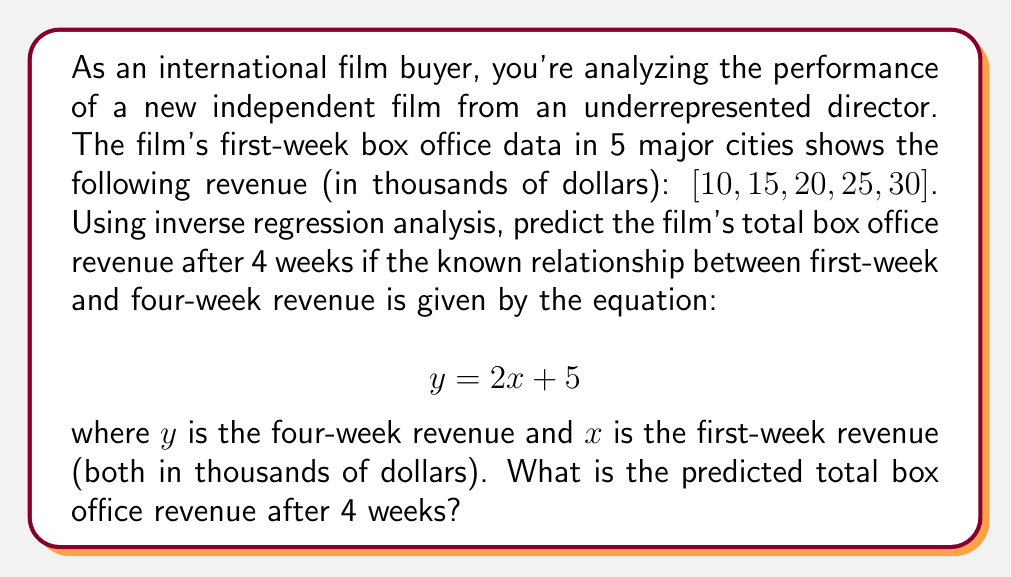Teach me how to tackle this problem. To solve this problem using inverse regression analysis, we'll follow these steps:

1) First, we need to calculate the average first-week revenue:

   $\bar{x} = \frac{10 + 15 + 20 + 25 + 30}{5} = 20$ thousand dollars

2) We're given the forward regression equation: $y = 2x + 5$

3) To perform inverse regression, we need to invert this equation:

   $x = \frac{y - 5}{2}$

4) Now, we can use this inverse equation to predict $y$ (four-week revenue) based on our average first-week revenue $\bar{x}$:

   $20 = \frac{y - 5}{2}$

5) Solve for $y$:

   $40 = y - 5$
   $y = 45$

Therefore, the predicted total box office revenue after 4 weeks is 45 thousand dollars.
Answer: $45,000 